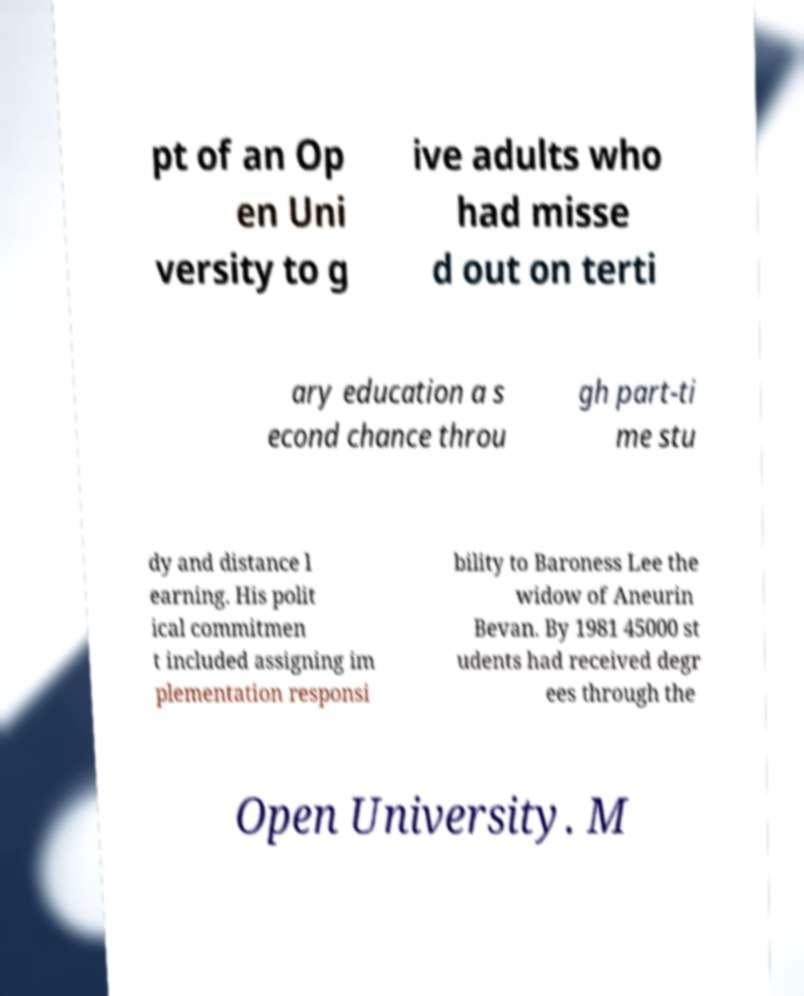Please identify and transcribe the text found in this image. pt of an Op en Uni versity to g ive adults who had misse d out on terti ary education a s econd chance throu gh part-ti me stu dy and distance l earning. His polit ical commitmen t included assigning im plementation responsi bility to Baroness Lee the widow of Aneurin Bevan. By 1981 45000 st udents had received degr ees through the Open University. M 